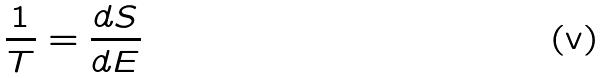Convert formula to latex. <formula><loc_0><loc_0><loc_500><loc_500>\frac { 1 } { T } = \frac { d S } { d E }</formula> 